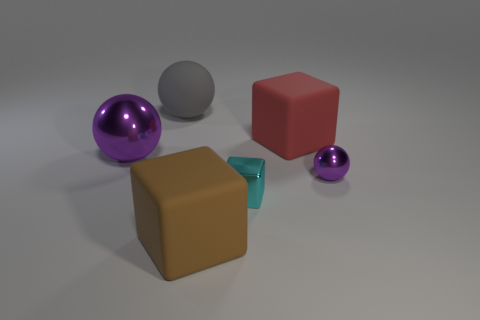How would the image change if it were set outdoors? If this scene were set outdoors, we might expect more dynamic lighting, with stronger highlights and shadows, especially if it's sunny. The objects might also show reflections of the surrounding environment, such as trees, sky, or buildings, potentially altering their apparent colors and textures. 